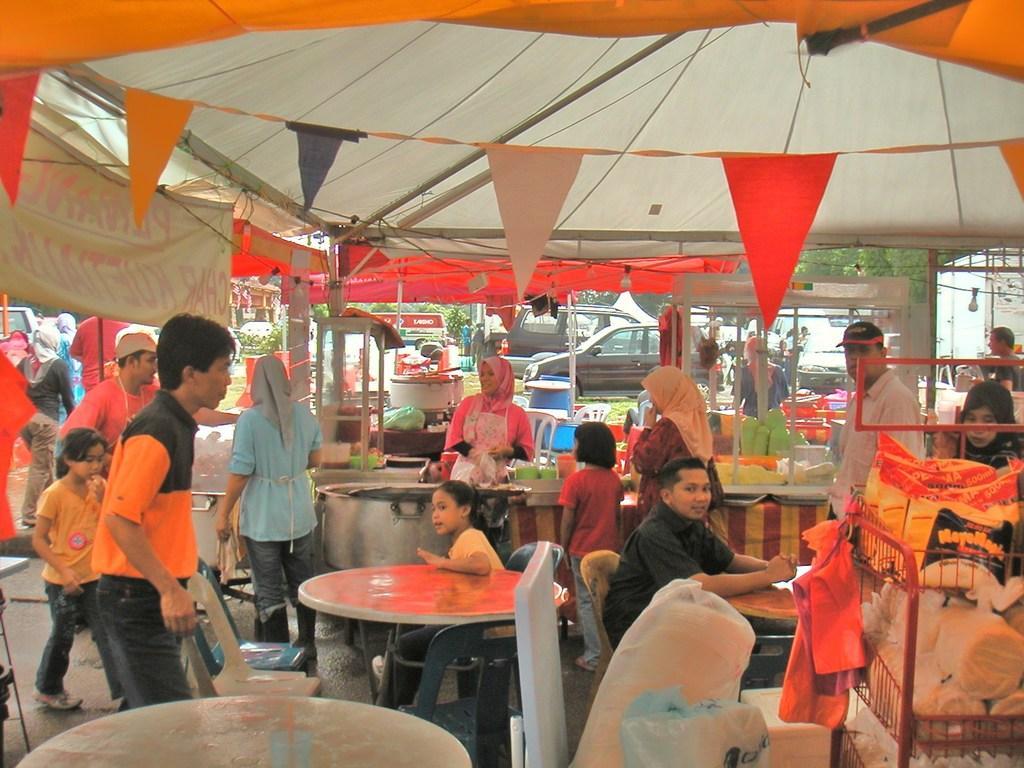Describe this image in one or two sentences. In this picture, it looks like a canopy tent. In the tent there are groups of people, chairs, tables, bulbs and other objects. Behind the people there are vehicles and trees. On the left side of the image there is a banner. 